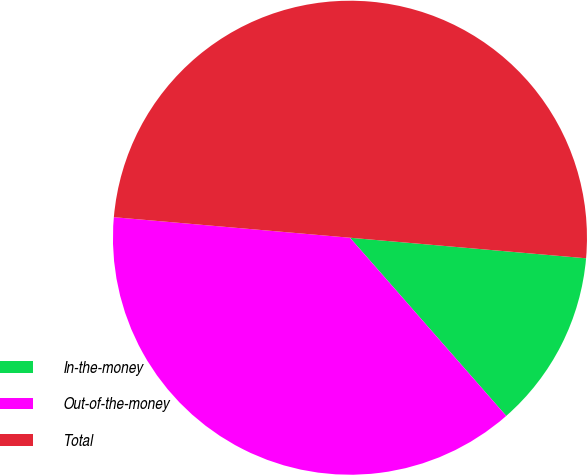<chart> <loc_0><loc_0><loc_500><loc_500><pie_chart><fcel>In-the-money<fcel>Out-of-the-money<fcel>Total<nl><fcel>12.16%<fcel>37.84%<fcel>50.0%<nl></chart> 